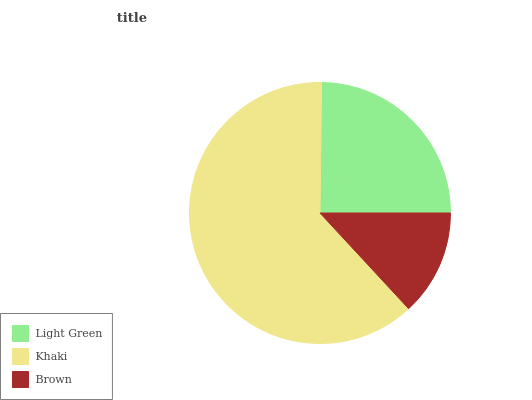Is Brown the minimum?
Answer yes or no. Yes. Is Khaki the maximum?
Answer yes or no. Yes. Is Khaki the minimum?
Answer yes or no. No. Is Brown the maximum?
Answer yes or no. No. Is Khaki greater than Brown?
Answer yes or no. Yes. Is Brown less than Khaki?
Answer yes or no. Yes. Is Brown greater than Khaki?
Answer yes or no. No. Is Khaki less than Brown?
Answer yes or no. No. Is Light Green the high median?
Answer yes or no. Yes. Is Light Green the low median?
Answer yes or no. Yes. Is Brown the high median?
Answer yes or no. No. Is Khaki the low median?
Answer yes or no. No. 